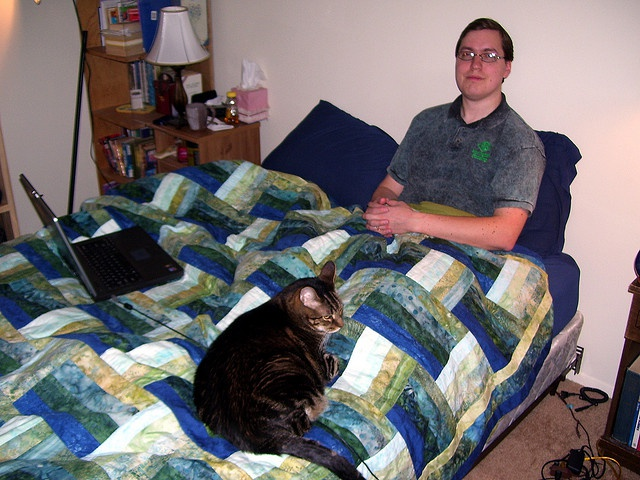Describe the objects in this image and their specific colors. I can see bed in tan, black, gray, navy, and lightgray tones, people in tan, gray, black, and brown tones, cat in tan, black, gray, maroon, and lightgray tones, laptop in tan, black, gray, and navy tones, and cup in tan, black, and gray tones in this image. 